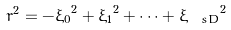Convert formula to latex. <formula><loc_0><loc_0><loc_500><loc_500>r ^ { 2 } = - { \xi _ { 0 } } ^ { 2 } + { \xi _ { 1 } } ^ { 2 } + \cdots + { \xi _ { \ s D } } ^ { 2 }</formula> 